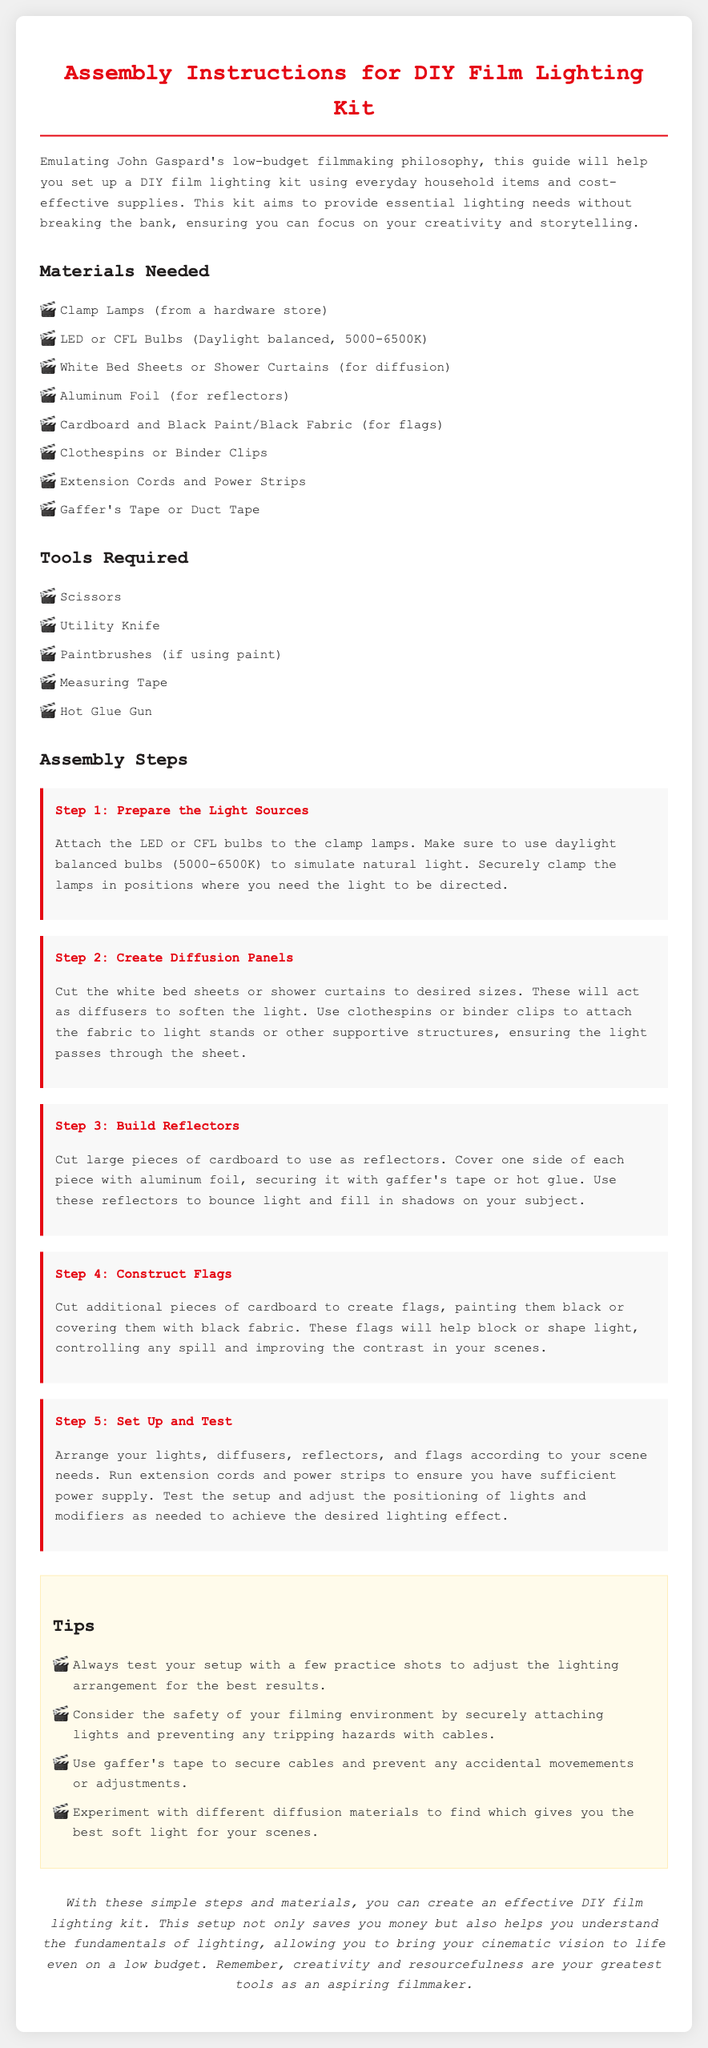what is the first step in the assembly instructions? The first step in the assembly instructions is to prepare the light sources.
Answer: Prepare the Light Sources how many materials are listed for the DIY Film Lighting Kit? The document lists eight materials needed for the DIY Film Lighting Kit.
Answer: Eight what type of bulbs should be used for the clamp lamps? The document specifies that daylight balanced bulbs (5000-6500K) should be used.
Answer: Daylight balanced bulbs (5000-6500K) which tools are required for the assembly? The document lists five tools required for the assembly.
Answer: Five tools what is the main purpose of diffusion panels in this setup? Diffusion panels are used to soften the light.
Answer: To soften the light which item is recommended for securing cables? The document recommends using gaffer's tape or duct tape for securing cables.
Answer: Gaffer's Tape or Duct Tape how can reflectors be constructed according to the instructions? Reflectors can be constructed by cutting cardboard and covering one side with aluminum foil.
Answer: Cutting cardboard and covering with aluminum foil what is a recommended action before filming? It is recommended to test the setup with a few practice shots.
Answer: Test the setup with practice shots what color should flags be painted? Flags should be painted black or covered with black fabric.
Answer: Black 